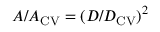<formula> <loc_0><loc_0><loc_500><loc_500>A / A _ { C V } = ( D / D _ { C V } ) ^ { 2 }</formula> 